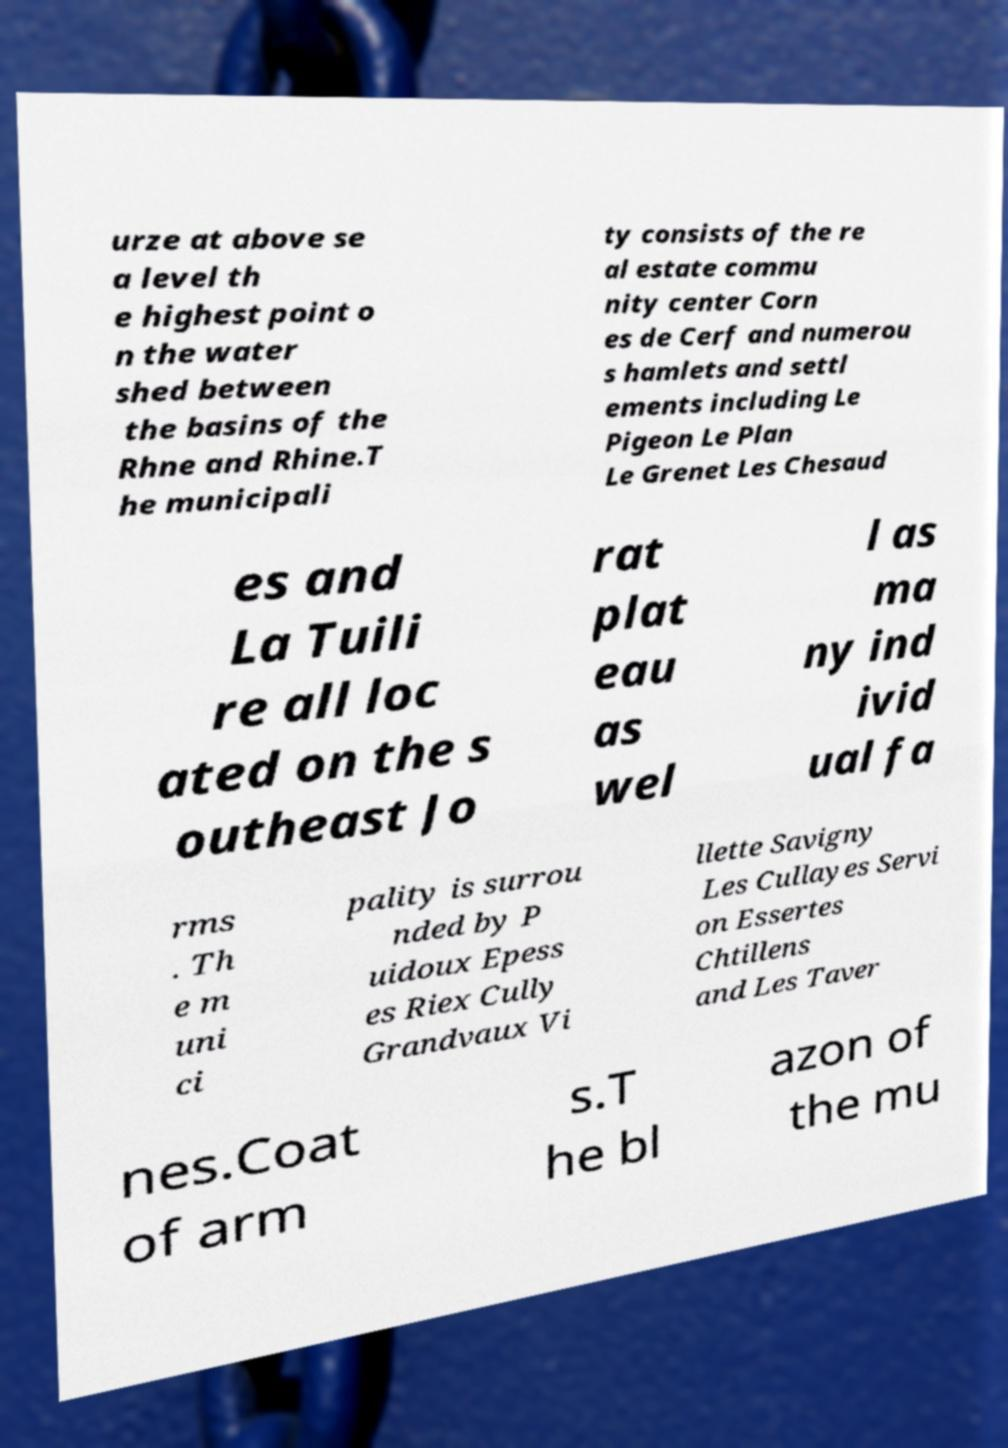There's text embedded in this image that I need extracted. Can you transcribe it verbatim? urze at above se a level th e highest point o n the water shed between the basins of the Rhne and Rhine.T he municipali ty consists of the re al estate commu nity center Corn es de Cerf and numerou s hamlets and settl ements including Le Pigeon Le Plan Le Grenet Les Chesaud es and La Tuili re all loc ated on the s outheast Jo rat plat eau as wel l as ma ny ind ivid ual fa rms . Th e m uni ci pality is surrou nded by P uidoux Epess es Riex Cully Grandvaux Vi llette Savigny Les Cullayes Servi on Essertes Chtillens and Les Taver nes.Coat of arm s.T he bl azon of the mu 